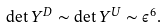<formula> <loc_0><loc_0><loc_500><loc_500>\det Y ^ { D } \sim \det Y ^ { U } \sim \epsilon ^ { 6 } .</formula> 